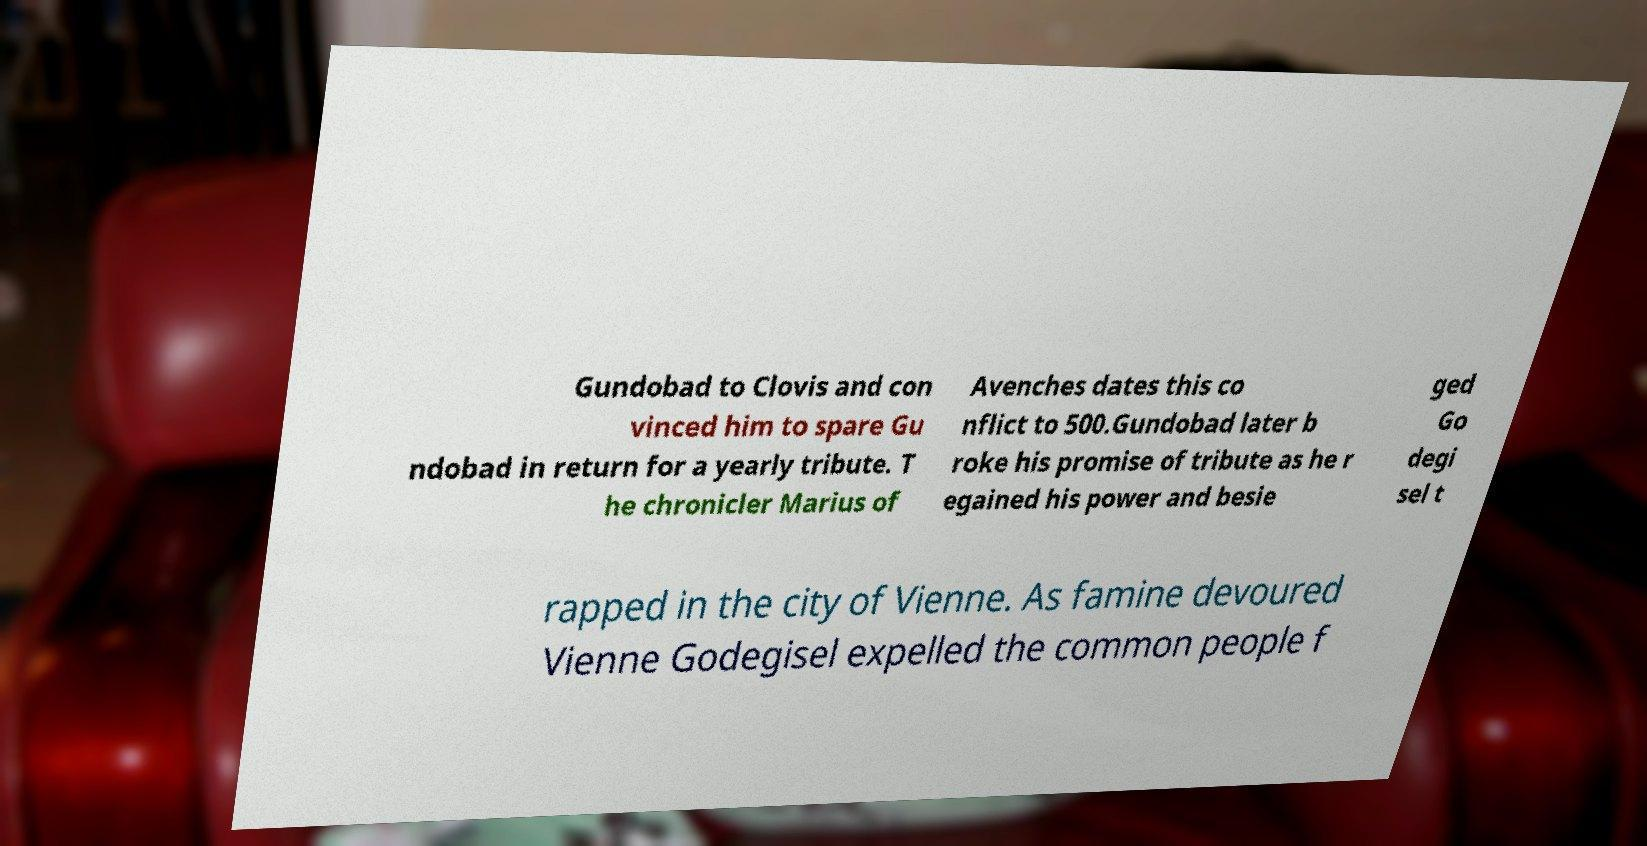Can you read and provide the text displayed in the image?This photo seems to have some interesting text. Can you extract and type it out for me? Gundobad to Clovis and con vinced him to spare Gu ndobad in return for a yearly tribute. T he chronicler Marius of Avenches dates this co nflict to 500.Gundobad later b roke his promise of tribute as he r egained his power and besie ged Go degi sel t rapped in the city of Vienne. As famine devoured Vienne Godegisel expelled the common people f 